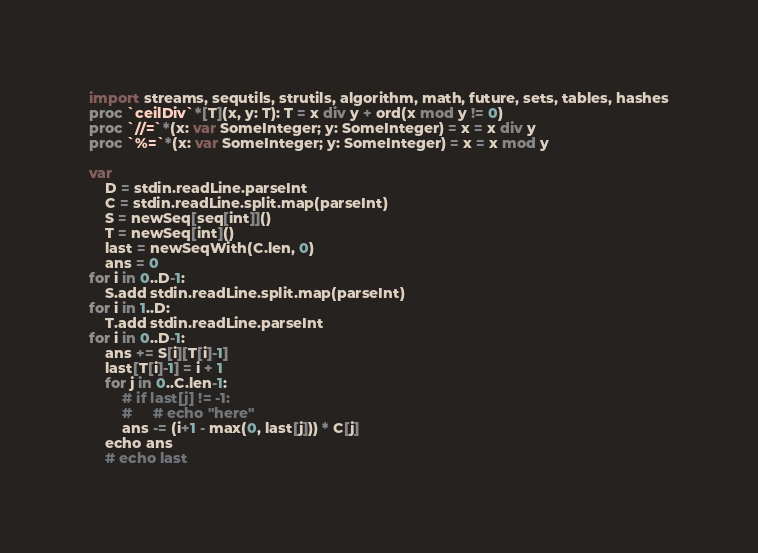Convert code to text. <code><loc_0><loc_0><loc_500><loc_500><_Nim_>import streams, sequtils, strutils, algorithm, math, future, sets, tables, hashes
proc `ceilDiv`*[T](x, y: T): T = x div y + ord(x mod y != 0)
proc `//=`*(x: var SomeInteger; y: SomeInteger) = x = x div y
proc `%=`*(x: var SomeInteger; y: SomeInteger) = x = x mod y

var
    D = stdin.readLine.parseInt
    C = stdin.readLine.split.map(parseInt)
    S = newSeq[seq[int]]()
    T = newSeq[int]()
    last = newSeqWith(C.len, 0)
    ans = 0
for i in 0..D-1:
    S.add stdin.readLine.split.map(parseInt)
for i in 1..D:
    T.add stdin.readLine.parseInt
for i in 0..D-1:
    ans += S[i][T[i]-1]
    last[T[i]-1] = i + 1
    for j in 0..C.len-1:
        # if last[j] != -1:
        #     # echo "here"
        ans -= (i+1 - max(0, last[j])) * C[j]
    echo ans
    # echo last
</code> 